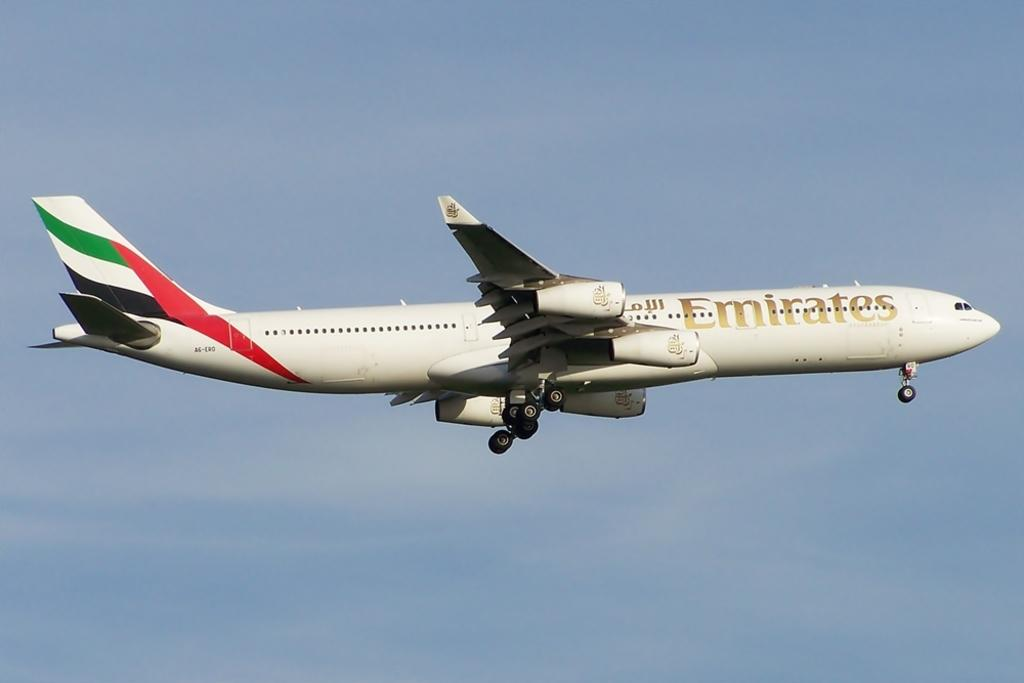<image>
Describe the image concisely. a white plane that has the word emirates on the side 